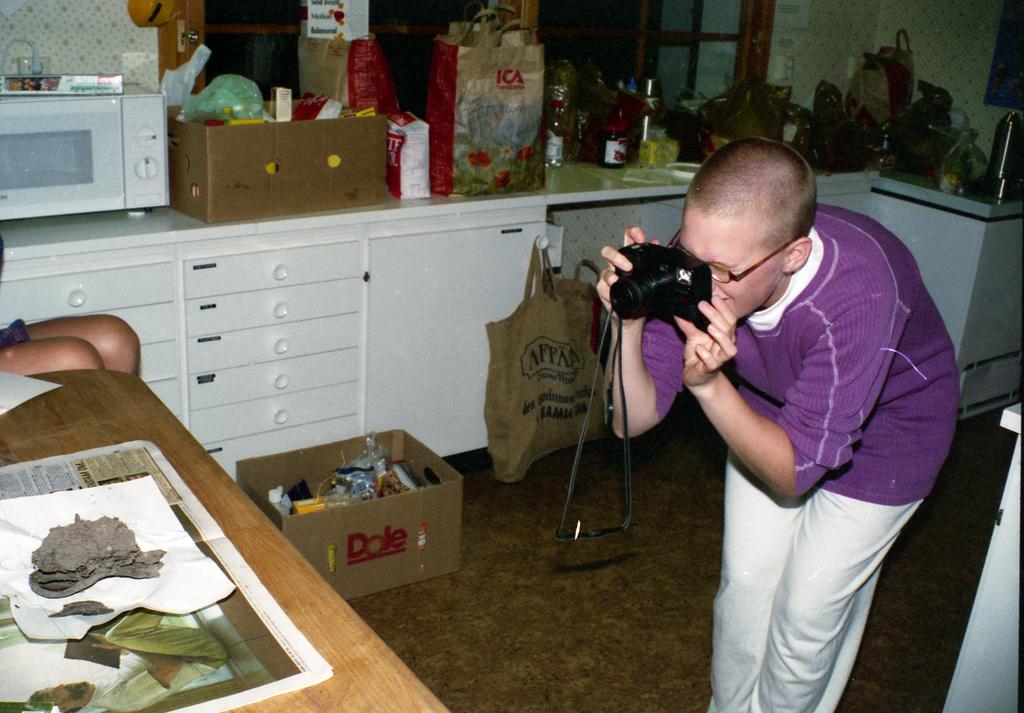What company name is on the box?
Your answer should be compact. Dole. What is inside the box on the counter?
Your answer should be compact. Dole. 